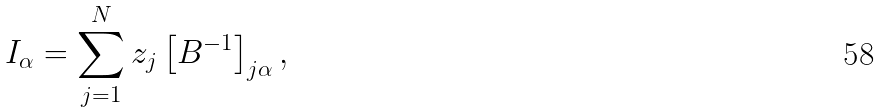Convert formula to latex. <formula><loc_0><loc_0><loc_500><loc_500>I _ { \alpha } = \sum _ { j = 1 } ^ { N } z _ { j } \left [ B ^ { - 1 } \right ] _ { j \alpha } ,</formula> 